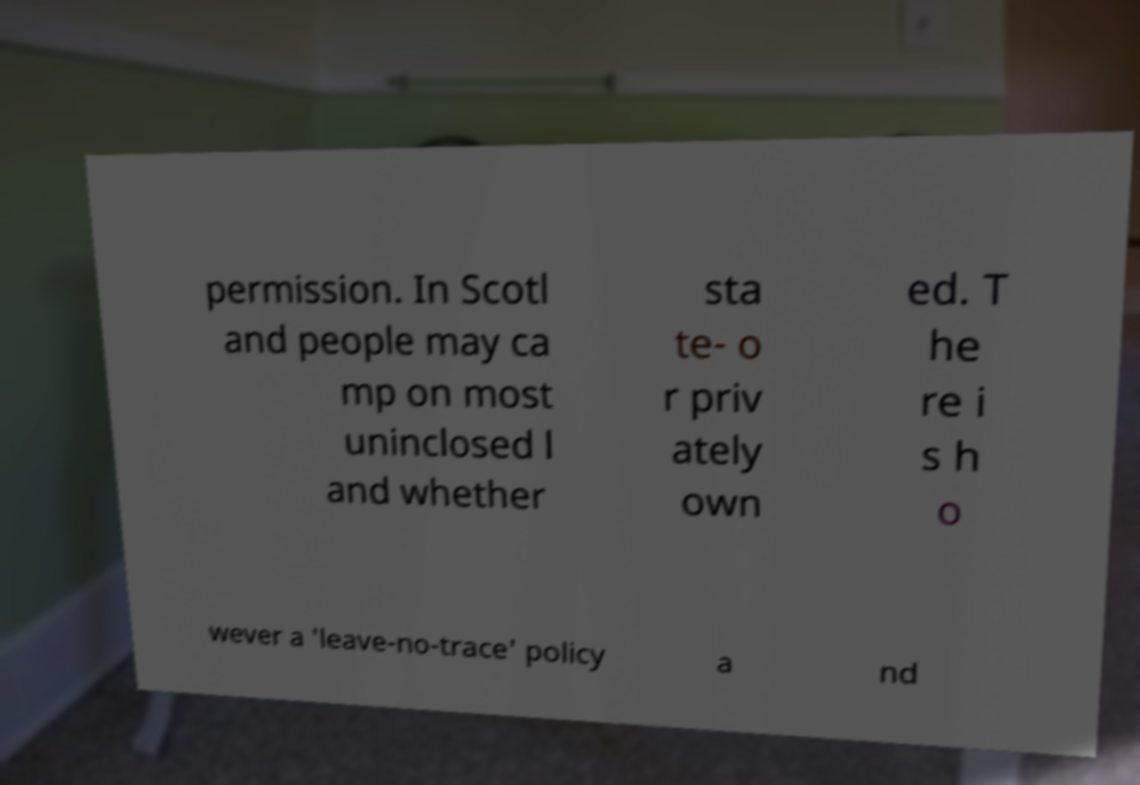Could you assist in decoding the text presented in this image and type it out clearly? permission. In Scotl and people may ca mp on most uninclosed l and whether sta te- o r priv ately own ed. T he re i s h o wever a 'leave-no-trace' policy a nd 